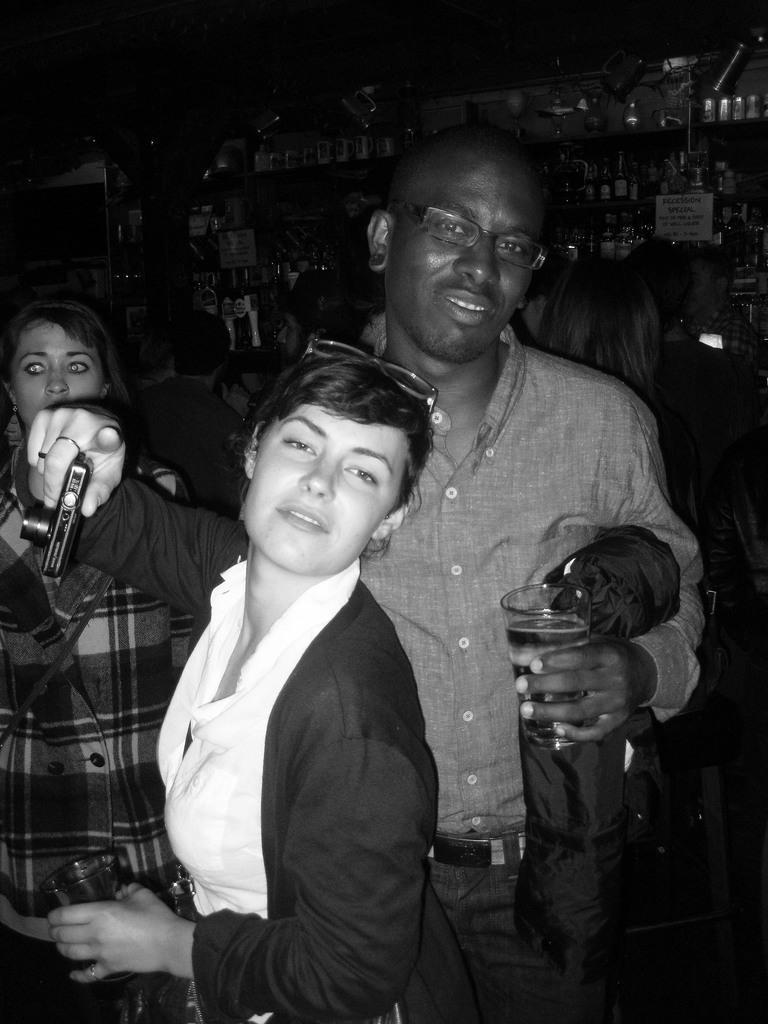Describe this image in one or two sentences. This is black and white image, in this image there are two women and a man holding a glass in his hand. 